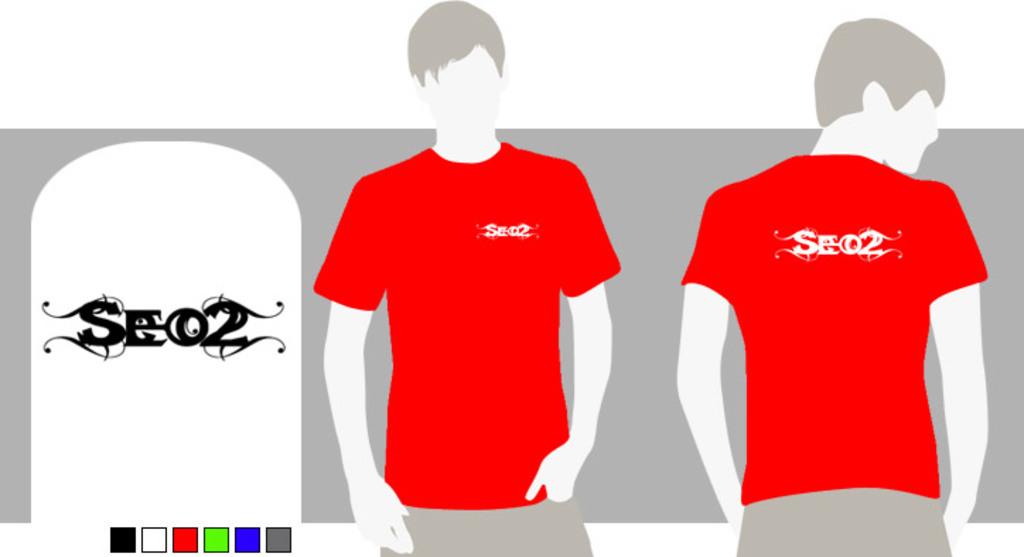What does that say on the front left of his shirt?
Make the answer very short. Seo2. 